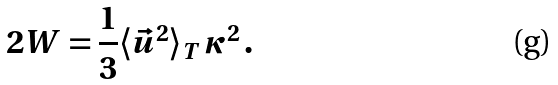<formula> <loc_0><loc_0><loc_500><loc_500>2 W = \frac { 1 } { 3 } \langle \vec { u } ^ { 2 } \rangle _ { T } \, \kappa ^ { 2 } \, .</formula> 